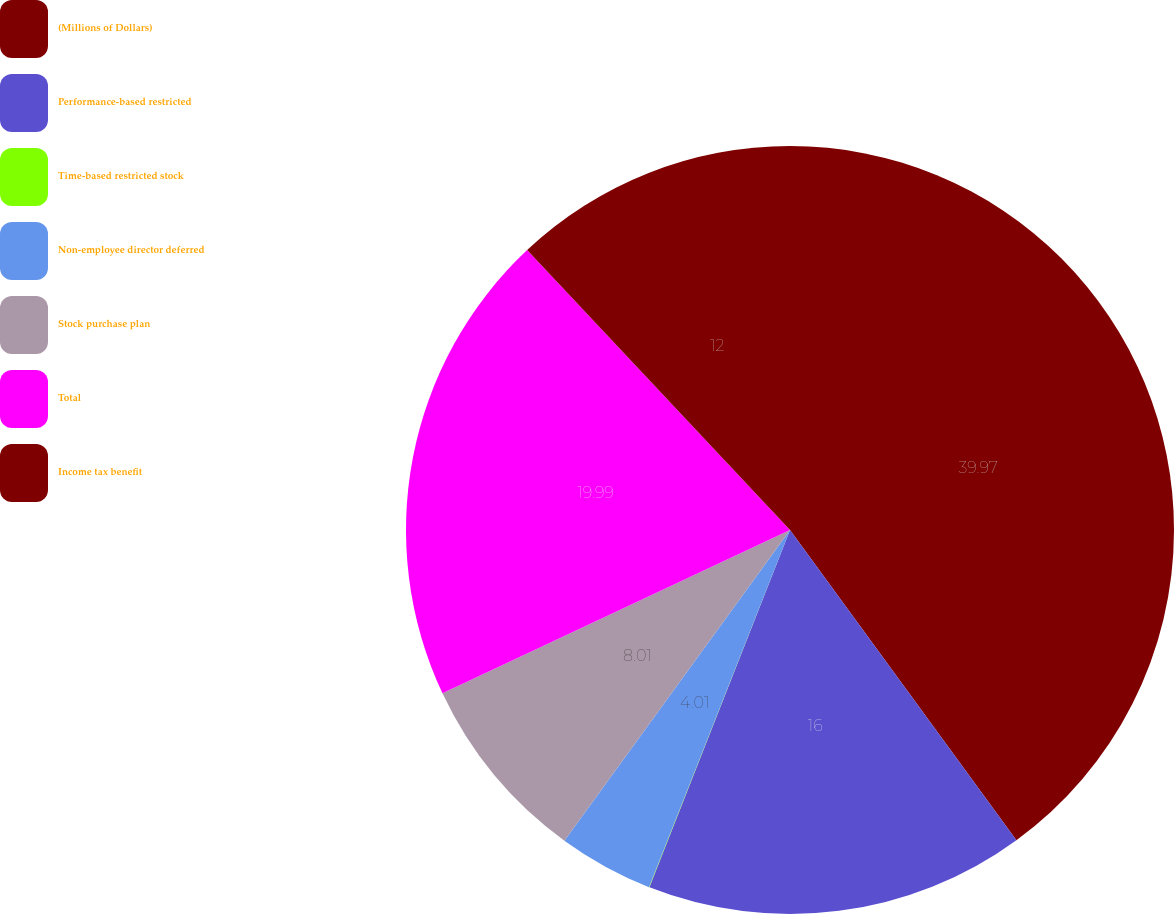Convert chart. <chart><loc_0><loc_0><loc_500><loc_500><pie_chart><fcel>(Millions of Dollars)<fcel>Performance-based restricted<fcel>Time-based restricted stock<fcel>Non-employee director deferred<fcel>Stock purchase plan<fcel>Total<fcel>Income tax benefit<nl><fcel>39.96%<fcel>16.0%<fcel>0.02%<fcel>4.01%<fcel>8.01%<fcel>19.99%<fcel>12.0%<nl></chart> 